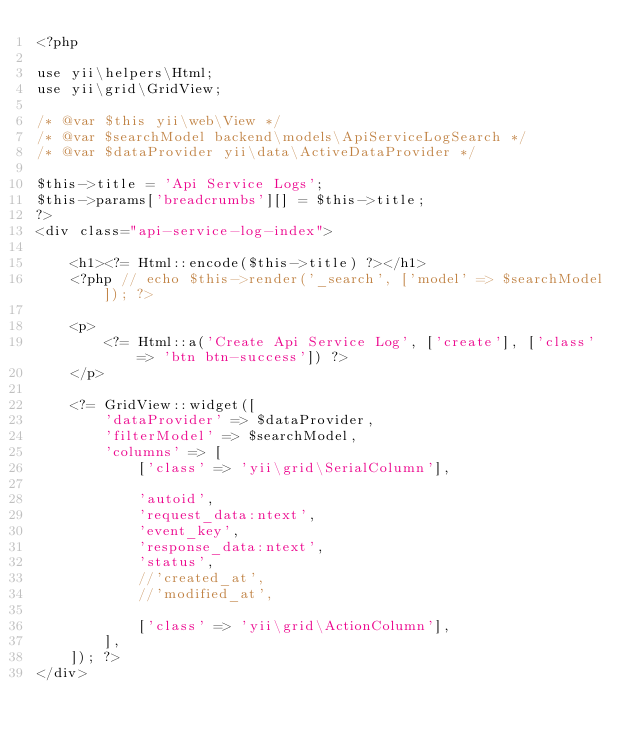<code> <loc_0><loc_0><loc_500><loc_500><_PHP_><?php

use yii\helpers\Html;
use yii\grid\GridView;

/* @var $this yii\web\View */
/* @var $searchModel backend\models\ApiServiceLogSearch */
/* @var $dataProvider yii\data\ActiveDataProvider */

$this->title = 'Api Service Logs';
$this->params['breadcrumbs'][] = $this->title;
?>
<div class="api-service-log-index">

    <h1><?= Html::encode($this->title) ?></h1>
    <?php // echo $this->render('_search', ['model' => $searchModel]); ?>

    <p>
        <?= Html::a('Create Api Service Log', ['create'], ['class' => 'btn btn-success']) ?>
    </p>

    <?= GridView::widget([
        'dataProvider' => $dataProvider,
        'filterModel' => $searchModel,
        'columns' => [
            ['class' => 'yii\grid\SerialColumn'],

            'autoid',
            'request_data:ntext',
            'event_key',
            'response_data:ntext',
            'status',
            //'created_at',
            //'modified_at',

            ['class' => 'yii\grid\ActionColumn'],
        ],
    ]); ?>
</div>
</code> 